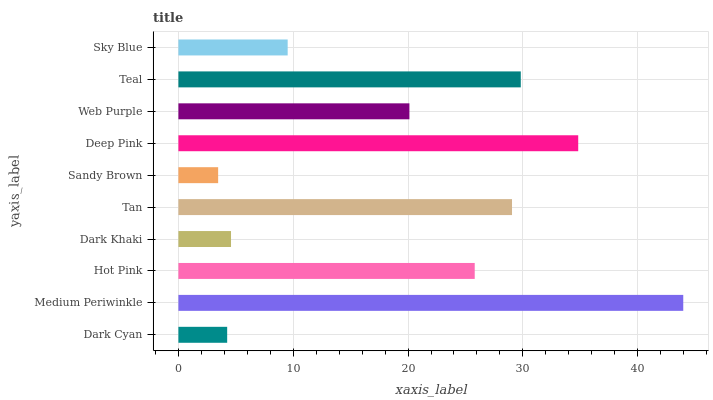Is Sandy Brown the minimum?
Answer yes or no. Yes. Is Medium Periwinkle the maximum?
Answer yes or no. Yes. Is Hot Pink the minimum?
Answer yes or no. No. Is Hot Pink the maximum?
Answer yes or no. No. Is Medium Periwinkle greater than Hot Pink?
Answer yes or no. Yes. Is Hot Pink less than Medium Periwinkle?
Answer yes or no. Yes. Is Hot Pink greater than Medium Periwinkle?
Answer yes or no. No. Is Medium Periwinkle less than Hot Pink?
Answer yes or no. No. Is Hot Pink the high median?
Answer yes or no. Yes. Is Web Purple the low median?
Answer yes or no. Yes. Is Medium Periwinkle the high median?
Answer yes or no. No. Is Hot Pink the low median?
Answer yes or no. No. 